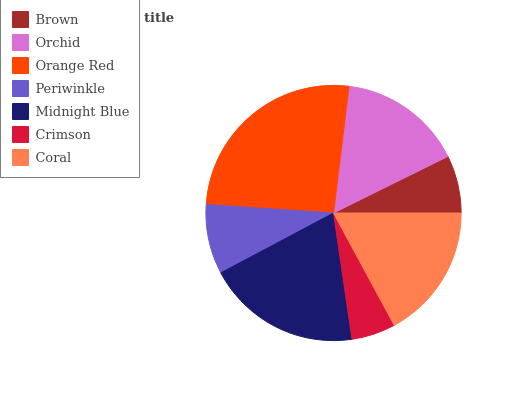Is Crimson the minimum?
Answer yes or no. Yes. Is Orange Red the maximum?
Answer yes or no. Yes. Is Orchid the minimum?
Answer yes or no. No. Is Orchid the maximum?
Answer yes or no. No. Is Orchid greater than Brown?
Answer yes or no. Yes. Is Brown less than Orchid?
Answer yes or no. Yes. Is Brown greater than Orchid?
Answer yes or no. No. Is Orchid less than Brown?
Answer yes or no. No. Is Orchid the high median?
Answer yes or no. Yes. Is Orchid the low median?
Answer yes or no. Yes. Is Crimson the high median?
Answer yes or no. No. Is Brown the low median?
Answer yes or no. No. 